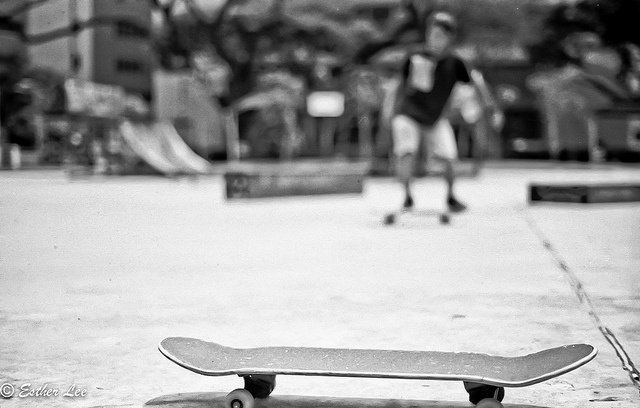Describe the objects in this image and their specific colors. I can see skateboard in black, lightgray, darkgray, and gray tones, people in black, gray, darkgray, and lightgray tones, and skateboard in darkgray, lightgray, gray, and black tones in this image. 